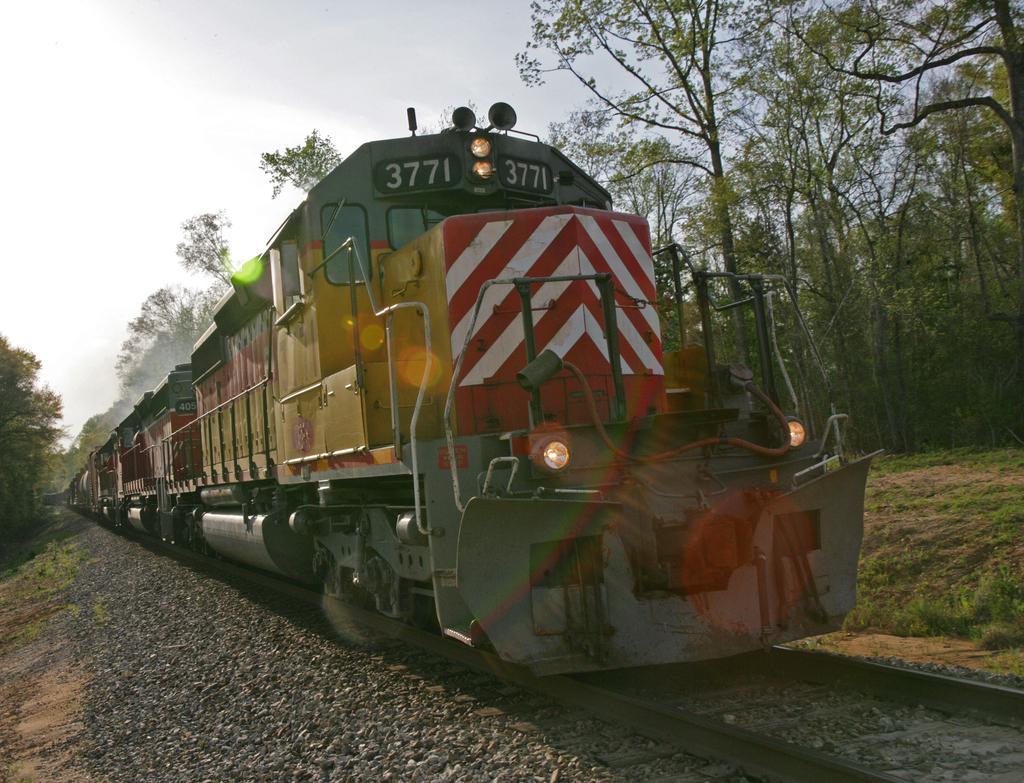How would you summarize this image in a sentence or two? In this image, we can see a train on the track. Here we can see grass, trees, plants and stones. Background there is the sky. 